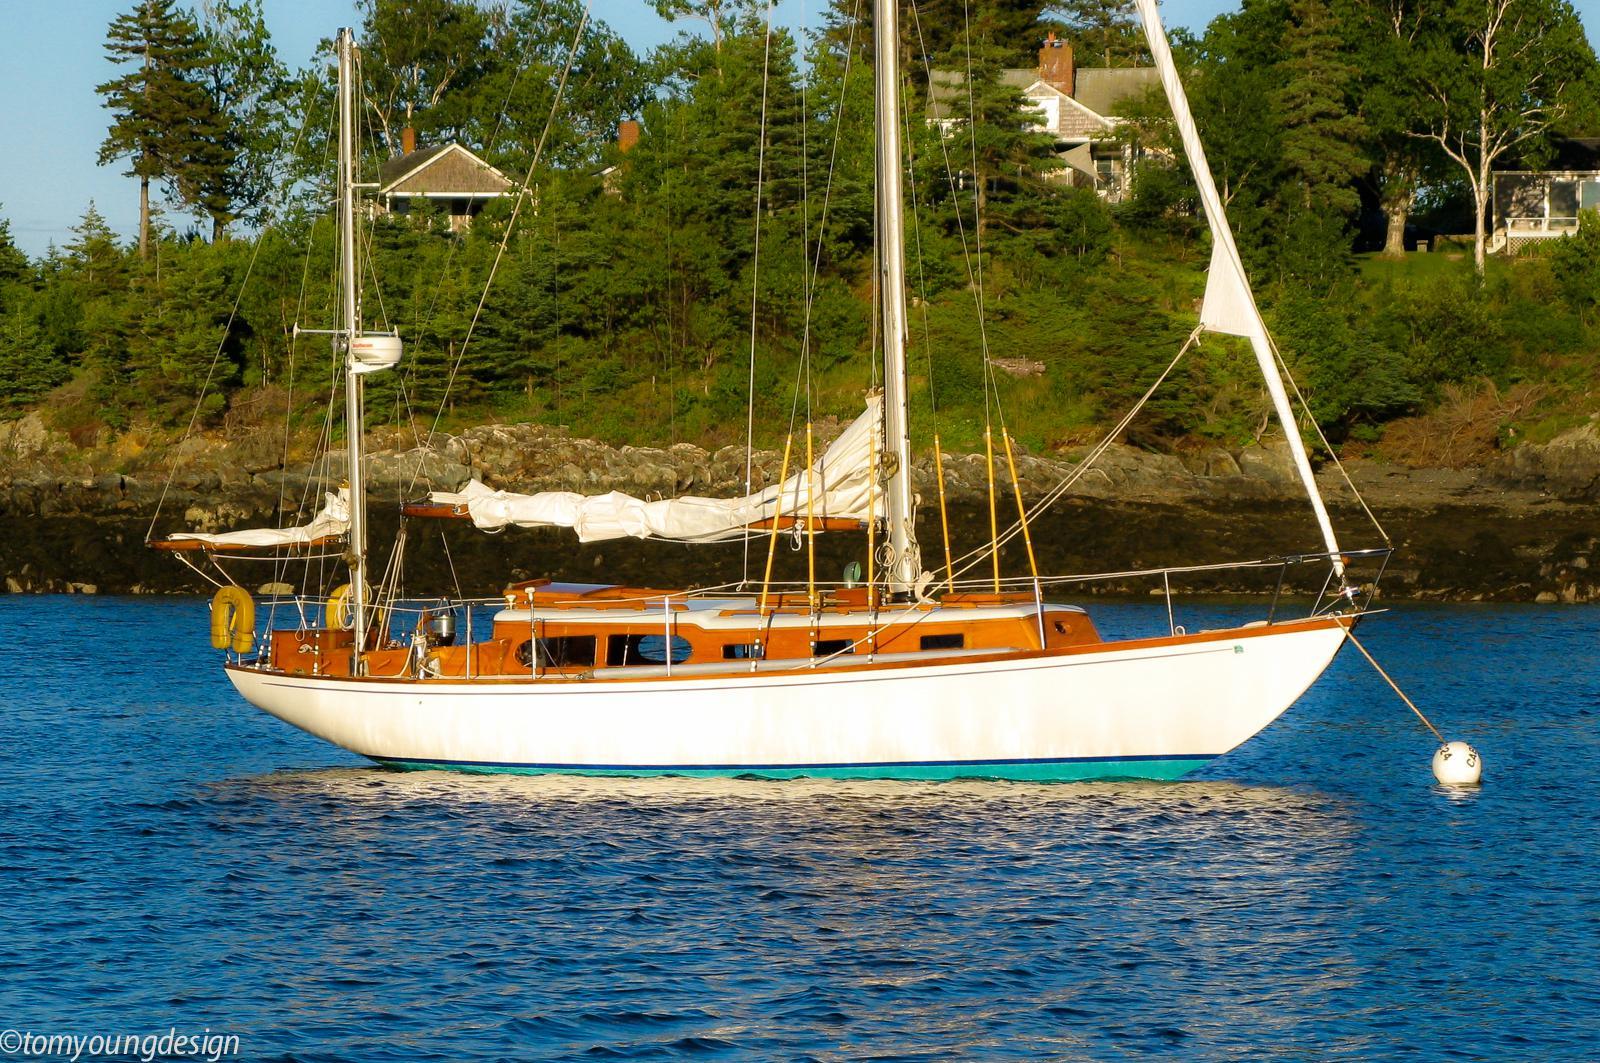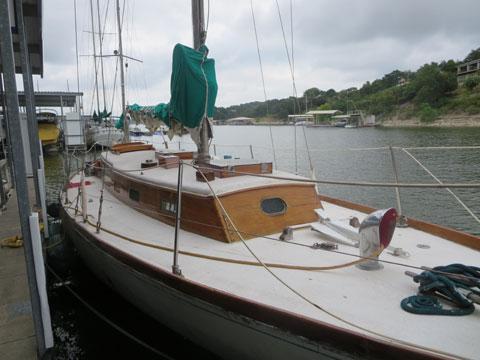The first image is the image on the left, the second image is the image on the right. Given the left and right images, does the statement "there are white inflated sails in the image on the right" hold true? Answer yes or no. No. 